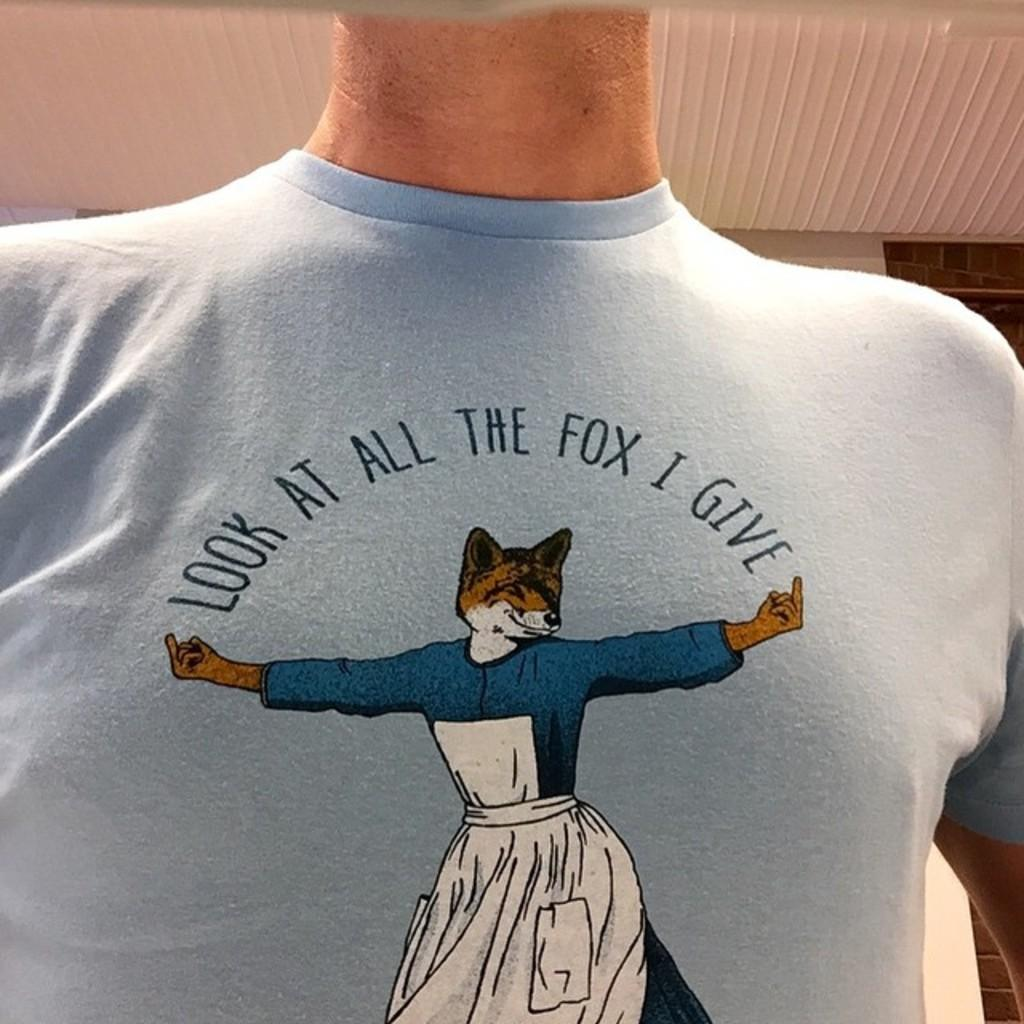What is present in the image? There is a person in the image. What is the person wearing? The person is wearing a t-shirt. What can be seen on the t-shirt? The t-shirt has a picture and text on it. What can be seen in the background of the image? There is a wall and a ceiling in the background of the image. What type of pump is visible in the image? There is no pump present in the image. What kind of animal can be seen interacting with the person in the image? There is no animal present in the image. 